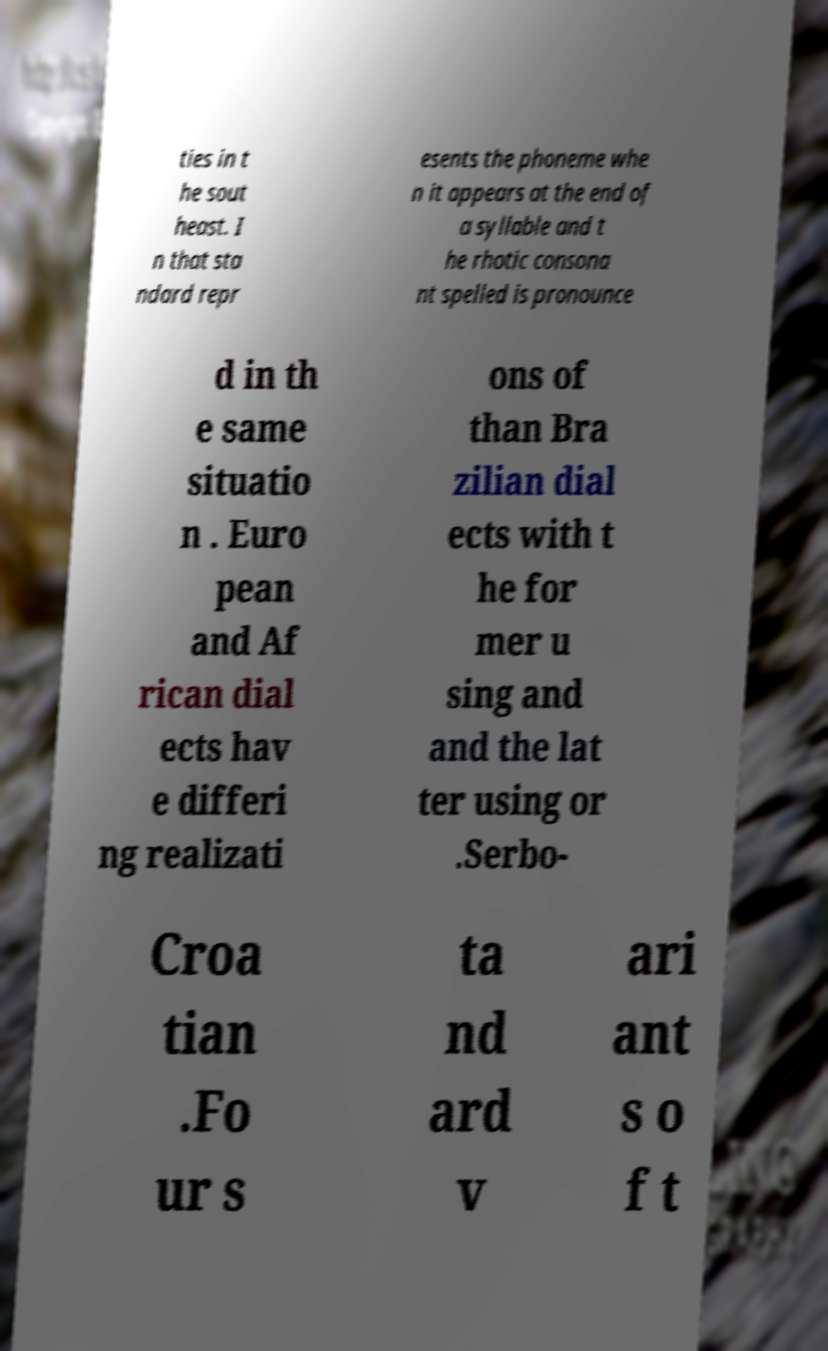Can you read and provide the text displayed in the image?This photo seems to have some interesting text. Can you extract and type it out for me? ties in t he sout heast. I n that sta ndard repr esents the phoneme whe n it appears at the end of a syllable and t he rhotic consona nt spelled is pronounce d in th e same situatio n . Euro pean and Af rican dial ects hav e differi ng realizati ons of than Bra zilian dial ects with t he for mer u sing and and the lat ter using or .Serbo- Croa tian .Fo ur s ta nd ard v ari ant s o f t 